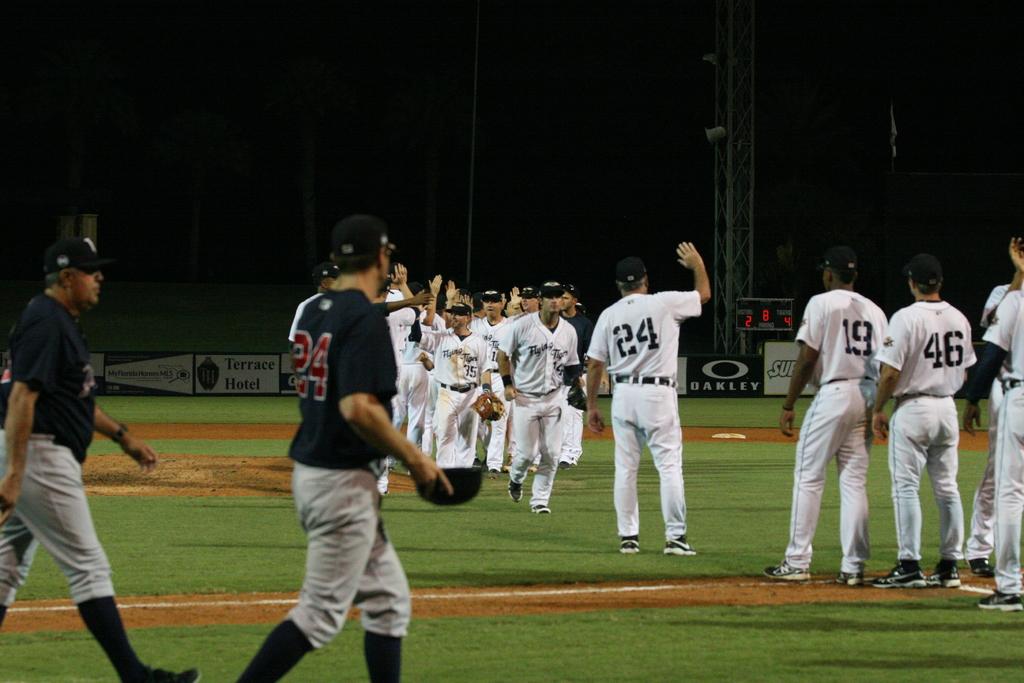What player number is the man in the black jersey wearing?
Your response must be concise. 24. What is the number of the closest player in white?
Provide a succinct answer. 46. 